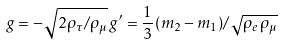Convert formula to latex. <formula><loc_0><loc_0><loc_500><loc_500>g = - \sqrt { 2 \rho _ { \tau } / \rho _ { \mu } } \, g ^ { \prime } = \frac { 1 } { 3 } ( m _ { 2 } - m _ { 1 } ) / \sqrt { \rho _ { e } \, \rho _ { \mu } }</formula> 